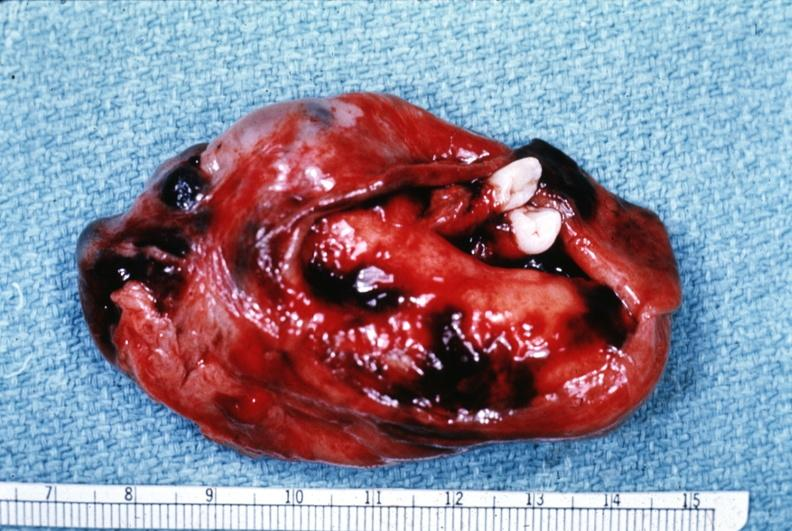s adenocarcinoma present?
Answer the question using a single word or phrase. No 